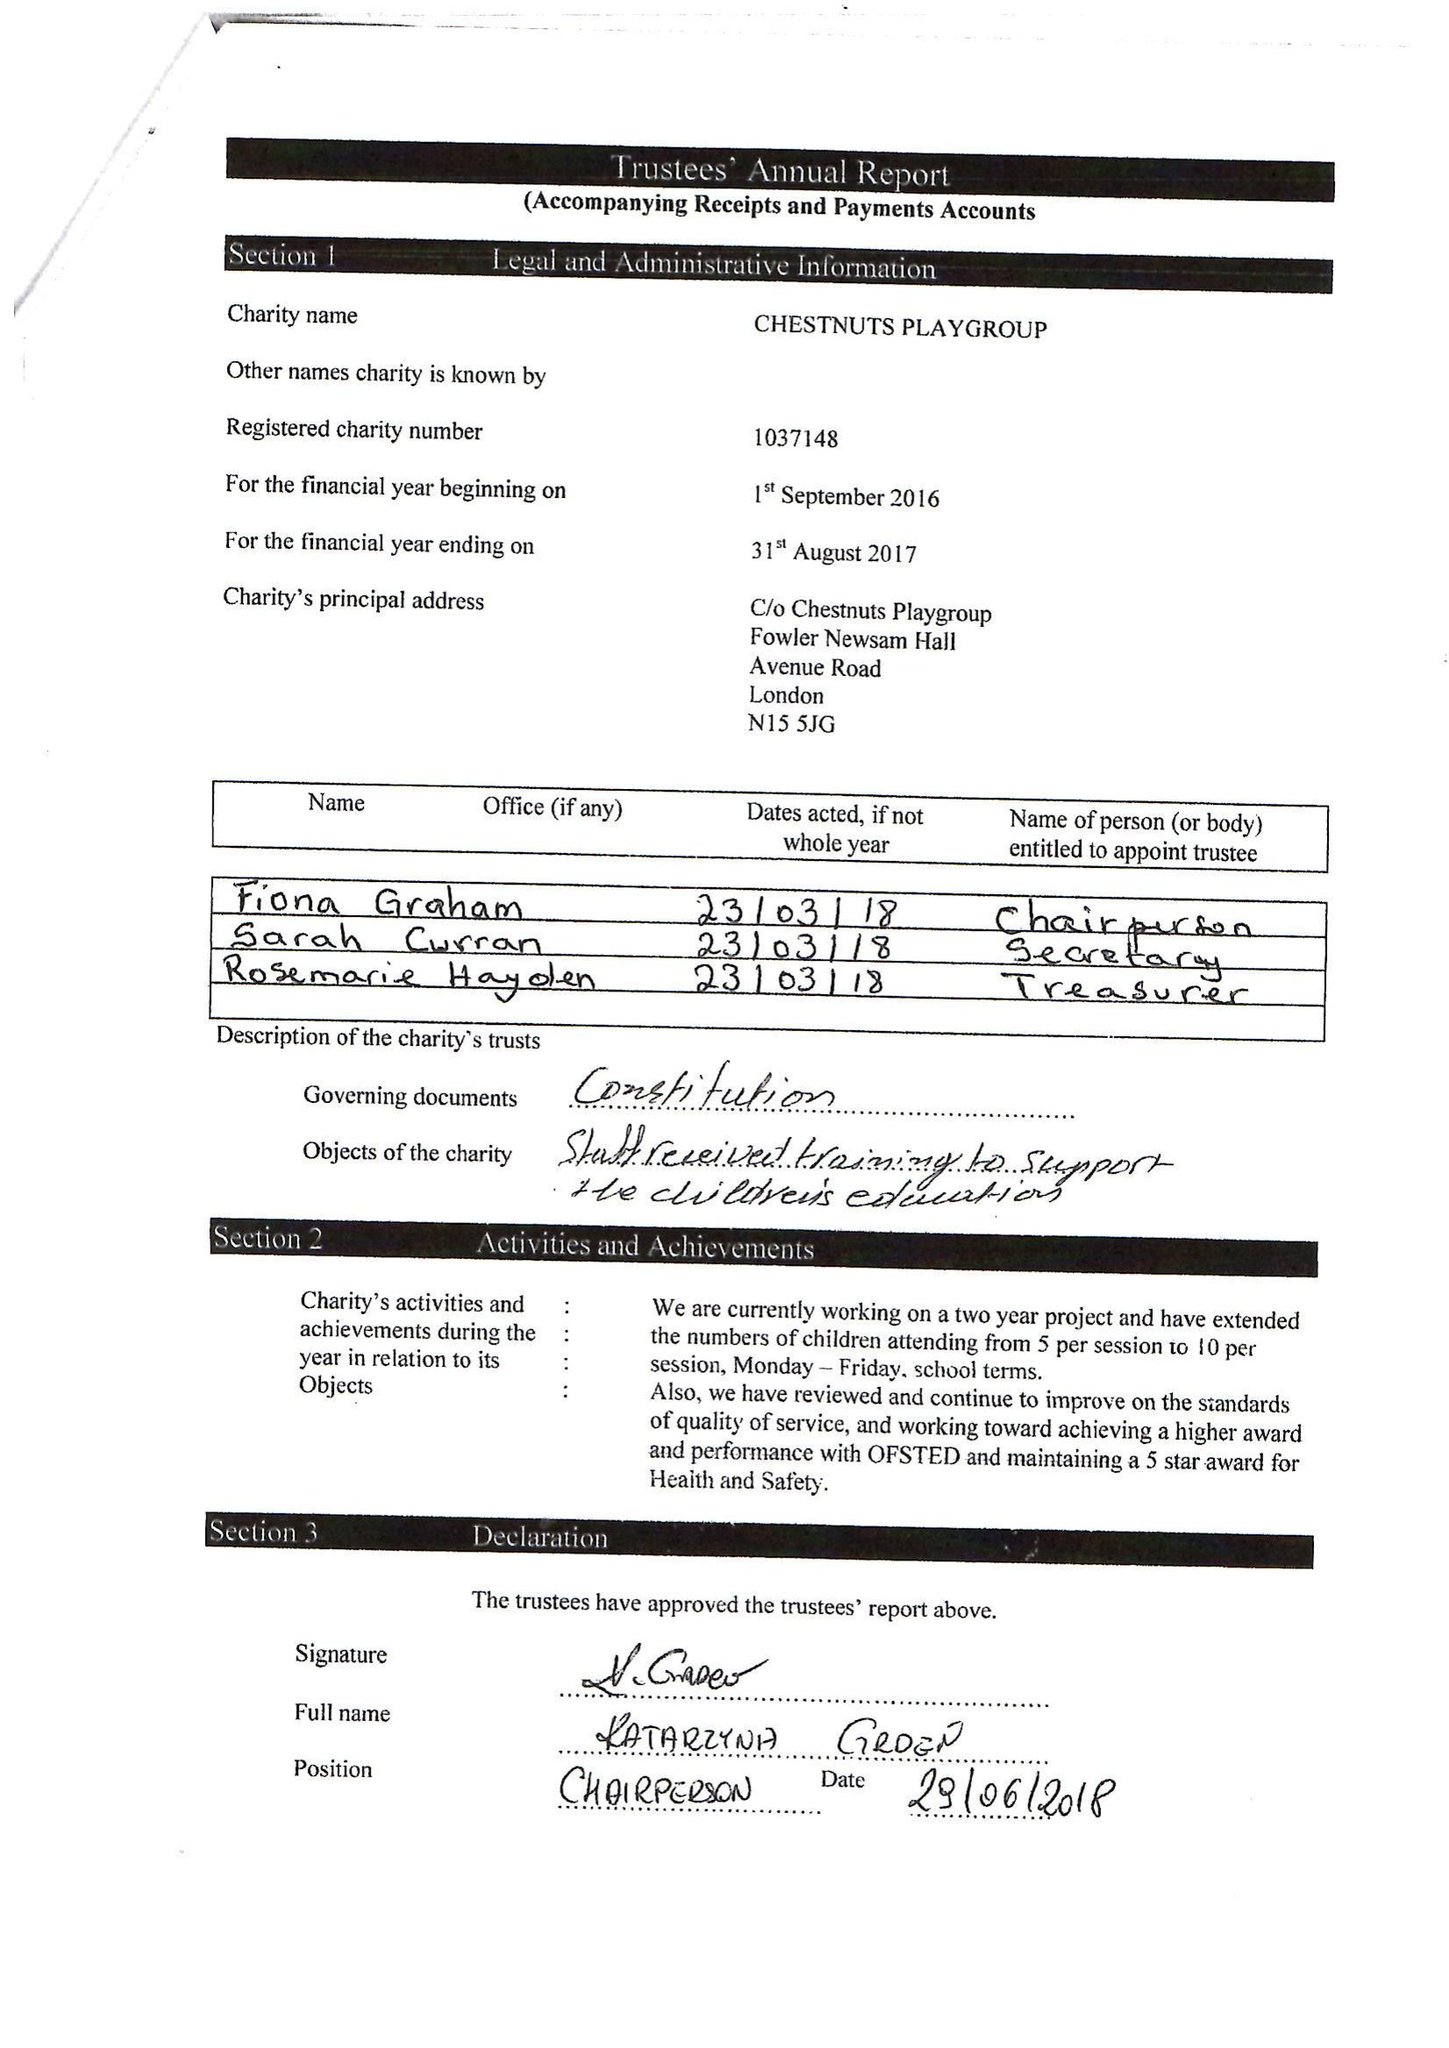What is the value for the charity_number?
Answer the question using a single word or phrase. 1037148 